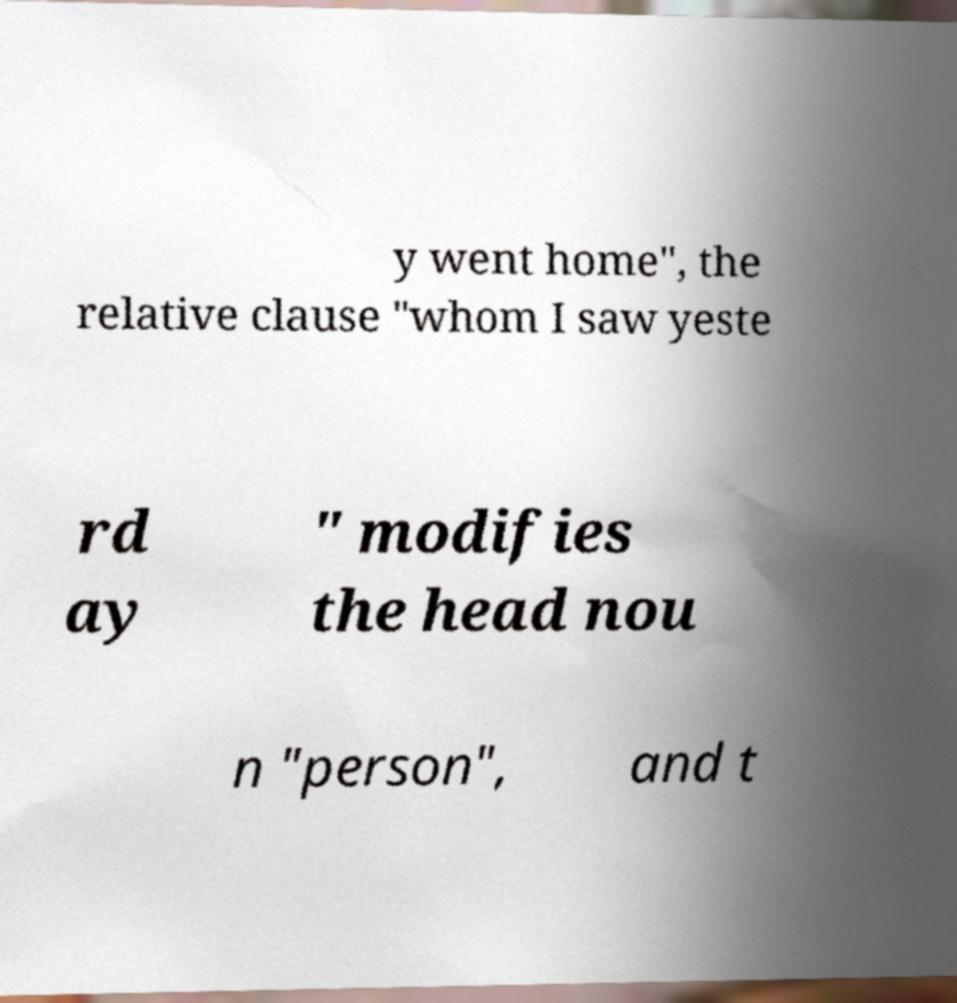There's text embedded in this image that I need extracted. Can you transcribe it verbatim? y went home", the relative clause "whom I saw yeste rd ay " modifies the head nou n "person", and t 